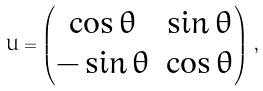Convert formula to latex. <formula><loc_0><loc_0><loc_500><loc_500>U = \begin{pmatrix} \cos \theta & \sin \theta \\ - \sin \theta & \cos \theta \end{pmatrix} \, ,</formula> 